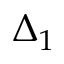Convert formula to latex. <formula><loc_0><loc_0><loc_500><loc_500>\Delta _ { 1 }</formula> 